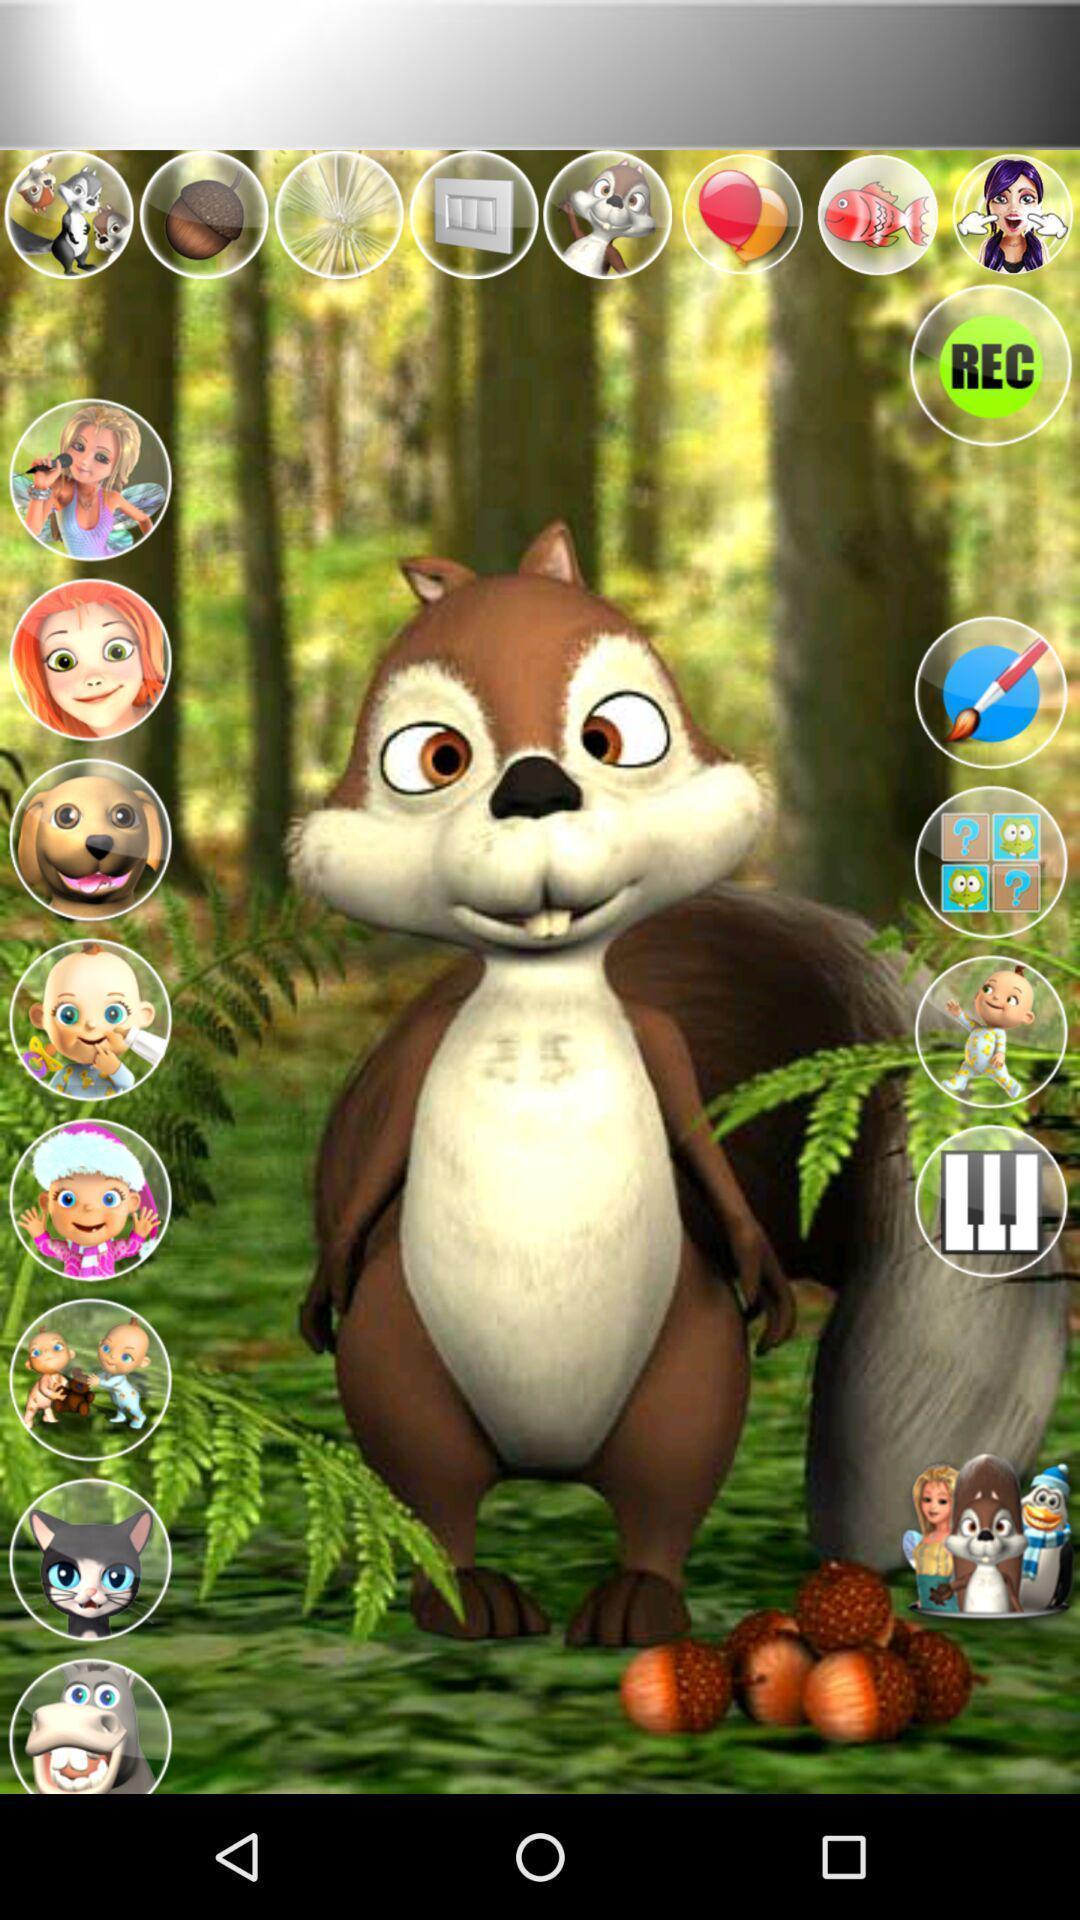Please provide a description for this image. Screen shows rabbit image in a gaming app. 